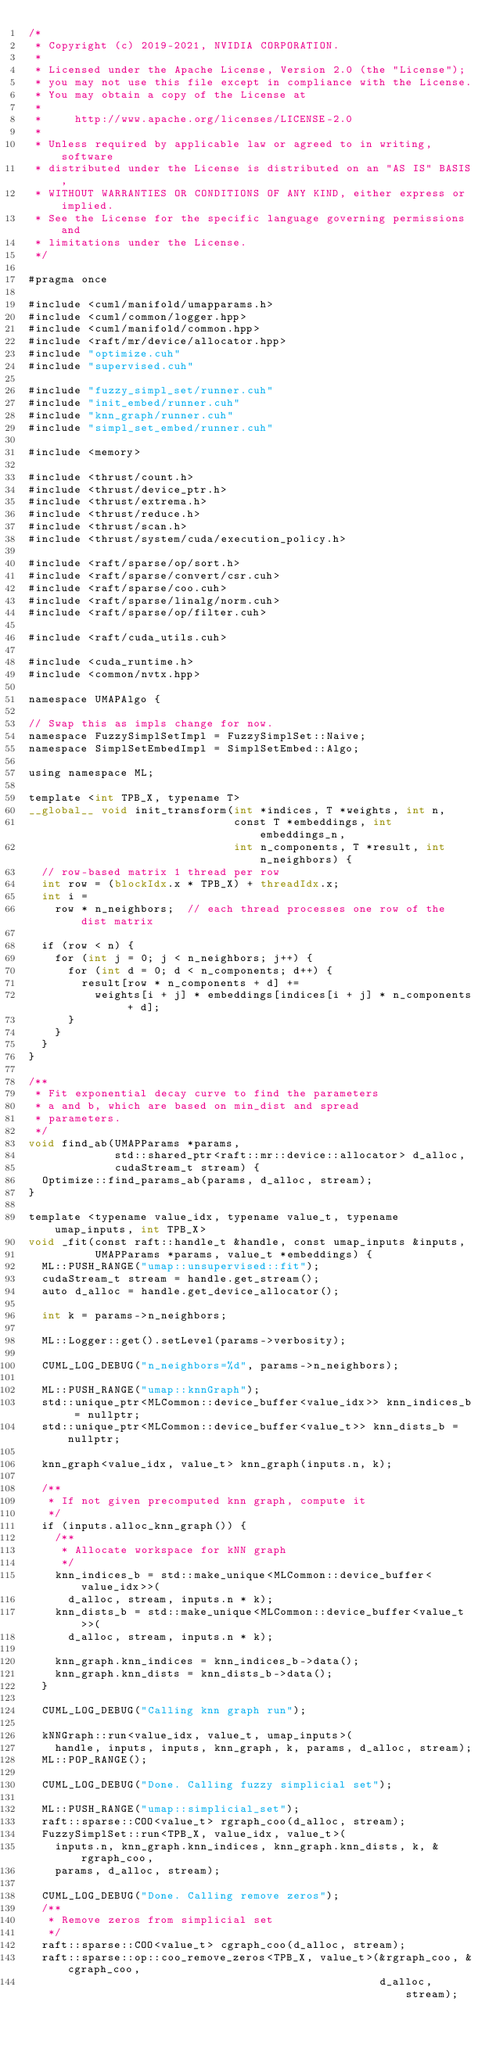Convert code to text. <code><loc_0><loc_0><loc_500><loc_500><_Cuda_>/*
 * Copyright (c) 2019-2021, NVIDIA CORPORATION.
 *
 * Licensed under the Apache License, Version 2.0 (the "License");
 * you may not use this file except in compliance with the License.
 * You may obtain a copy of the License at
 *
 *     http://www.apache.org/licenses/LICENSE-2.0
 *
 * Unless required by applicable law or agreed to in writing, software
 * distributed under the License is distributed on an "AS IS" BASIS,
 * WITHOUT WARRANTIES OR CONDITIONS OF ANY KIND, either express or implied.
 * See the License for the specific language governing permissions and
 * limitations under the License.
 */

#pragma once

#include <cuml/manifold/umapparams.h>
#include <cuml/common/logger.hpp>
#include <cuml/manifold/common.hpp>
#include <raft/mr/device/allocator.hpp>
#include "optimize.cuh"
#include "supervised.cuh"

#include "fuzzy_simpl_set/runner.cuh"
#include "init_embed/runner.cuh"
#include "knn_graph/runner.cuh"
#include "simpl_set_embed/runner.cuh"

#include <memory>

#include <thrust/count.h>
#include <thrust/device_ptr.h>
#include <thrust/extrema.h>
#include <thrust/reduce.h>
#include <thrust/scan.h>
#include <thrust/system/cuda/execution_policy.h>

#include <raft/sparse/op/sort.h>
#include <raft/sparse/convert/csr.cuh>
#include <raft/sparse/coo.cuh>
#include <raft/sparse/linalg/norm.cuh>
#include <raft/sparse/op/filter.cuh>

#include <raft/cuda_utils.cuh>

#include <cuda_runtime.h>
#include <common/nvtx.hpp>

namespace UMAPAlgo {

// Swap this as impls change for now.
namespace FuzzySimplSetImpl = FuzzySimplSet::Naive;
namespace SimplSetEmbedImpl = SimplSetEmbed::Algo;

using namespace ML;

template <int TPB_X, typename T>
__global__ void init_transform(int *indices, T *weights, int n,
                               const T *embeddings, int embeddings_n,
                               int n_components, T *result, int n_neighbors) {
  // row-based matrix 1 thread per row
  int row = (blockIdx.x * TPB_X) + threadIdx.x;
  int i =
    row * n_neighbors;  // each thread processes one row of the dist matrix

  if (row < n) {
    for (int j = 0; j < n_neighbors; j++) {
      for (int d = 0; d < n_components; d++) {
        result[row * n_components + d] +=
          weights[i + j] * embeddings[indices[i + j] * n_components + d];
      }
    }
  }
}

/**
 * Fit exponential decay curve to find the parameters
 * a and b, which are based on min_dist and spread
 * parameters.
 */
void find_ab(UMAPParams *params,
             std::shared_ptr<raft::mr::device::allocator> d_alloc,
             cudaStream_t stream) {
  Optimize::find_params_ab(params, d_alloc, stream);
}

template <typename value_idx, typename value_t, typename umap_inputs, int TPB_X>
void _fit(const raft::handle_t &handle, const umap_inputs &inputs,
          UMAPParams *params, value_t *embeddings) {
  ML::PUSH_RANGE("umap::unsupervised::fit");
  cudaStream_t stream = handle.get_stream();
  auto d_alloc = handle.get_device_allocator();

  int k = params->n_neighbors;

  ML::Logger::get().setLevel(params->verbosity);

  CUML_LOG_DEBUG("n_neighbors=%d", params->n_neighbors);

  ML::PUSH_RANGE("umap::knnGraph");
  std::unique_ptr<MLCommon::device_buffer<value_idx>> knn_indices_b = nullptr;
  std::unique_ptr<MLCommon::device_buffer<value_t>> knn_dists_b = nullptr;

  knn_graph<value_idx, value_t> knn_graph(inputs.n, k);

  /**
   * If not given precomputed knn graph, compute it
   */
  if (inputs.alloc_knn_graph()) {
    /**
     * Allocate workspace for kNN graph
     */
    knn_indices_b = std::make_unique<MLCommon::device_buffer<value_idx>>(
      d_alloc, stream, inputs.n * k);
    knn_dists_b = std::make_unique<MLCommon::device_buffer<value_t>>(
      d_alloc, stream, inputs.n * k);

    knn_graph.knn_indices = knn_indices_b->data();
    knn_graph.knn_dists = knn_dists_b->data();
  }

  CUML_LOG_DEBUG("Calling knn graph run");

  kNNGraph::run<value_idx, value_t, umap_inputs>(
    handle, inputs, inputs, knn_graph, k, params, d_alloc, stream);
  ML::POP_RANGE();

  CUML_LOG_DEBUG("Done. Calling fuzzy simplicial set");

  ML::PUSH_RANGE("umap::simplicial_set");
  raft::sparse::COO<value_t> rgraph_coo(d_alloc, stream);
  FuzzySimplSet::run<TPB_X, value_idx, value_t>(
    inputs.n, knn_graph.knn_indices, knn_graph.knn_dists, k, &rgraph_coo,
    params, d_alloc, stream);

  CUML_LOG_DEBUG("Done. Calling remove zeros");
  /**
   * Remove zeros from simplicial set
   */
  raft::sparse::COO<value_t> cgraph_coo(d_alloc, stream);
  raft::sparse::op::coo_remove_zeros<TPB_X, value_t>(&rgraph_coo, &cgraph_coo,
                                                     d_alloc, stream);</code> 